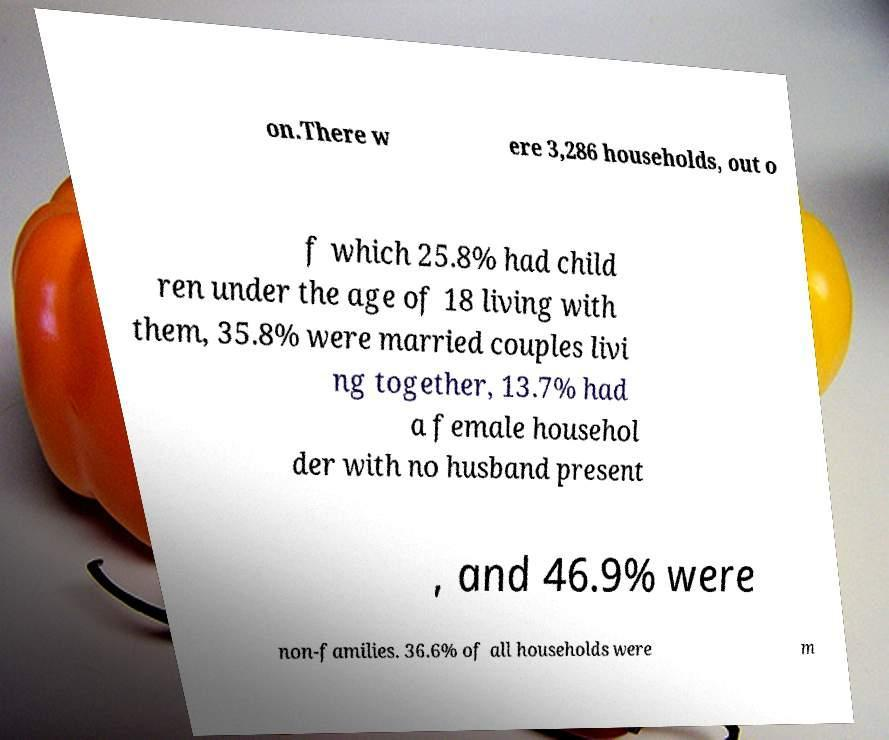Please identify and transcribe the text found in this image. on.There w ere 3,286 households, out o f which 25.8% had child ren under the age of 18 living with them, 35.8% were married couples livi ng together, 13.7% had a female househol der with no husband present , and 46.9% were non-families. 36.6% of all households were m 